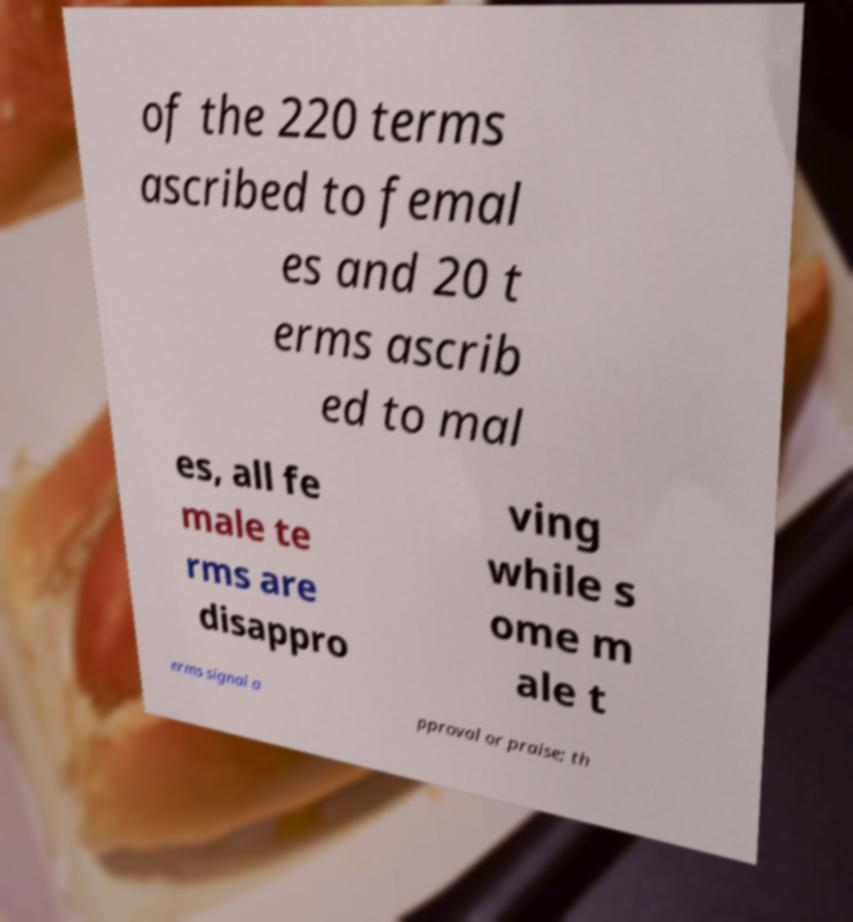Could you extract and type out the text from this image? of the 220 terms ascribed to femal es and 20 t erms ascrib ed to mal es, all fe male te rms are disappro ving while s ome m ale t erms signal a pproval or praise; th 